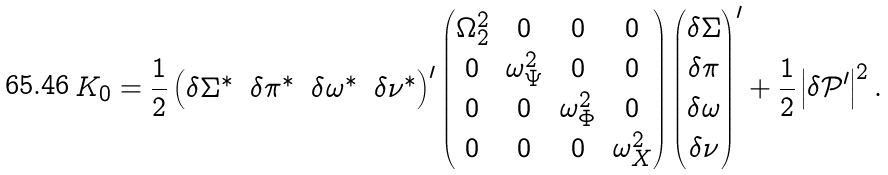<formula> <loc_0><loc_0><loc_500><loc_500>K _ { 0 } = \frac { 1 } { 2 } \begin{pmatrix} \delta \Sigma ^ { \ast } & \delta \pi ^ { \ast } & \delta \omega ^ { \ast } & \delta \nu ^ { \ast } \end{pmatrix} ^ { \prime } \begin{pmatrix} \Omega _ { 2 } ^ { 2 } & 0 & 0 & 0 \\ 0 & \omega _ { \Psi } ^ { 2 } & 0 & 0 \\ 0 & 0 & \omega _ { \Phi } ^ { 2 } & 0 \\ 0 & 0 & 0 & \omega _ { X } ^ { 2 } \end{pmatrix} \begin{pmatrix} \delta \Sigma \\ \delta \pi \\ \delta \omega \\ \delta \nu \end{pmatrix} ^ { \prime } + \frac { 1 } { 2 } \left | \delta { \mathcal { P } } ^ { \prime } \right | ^ { 2 } .</formula> 